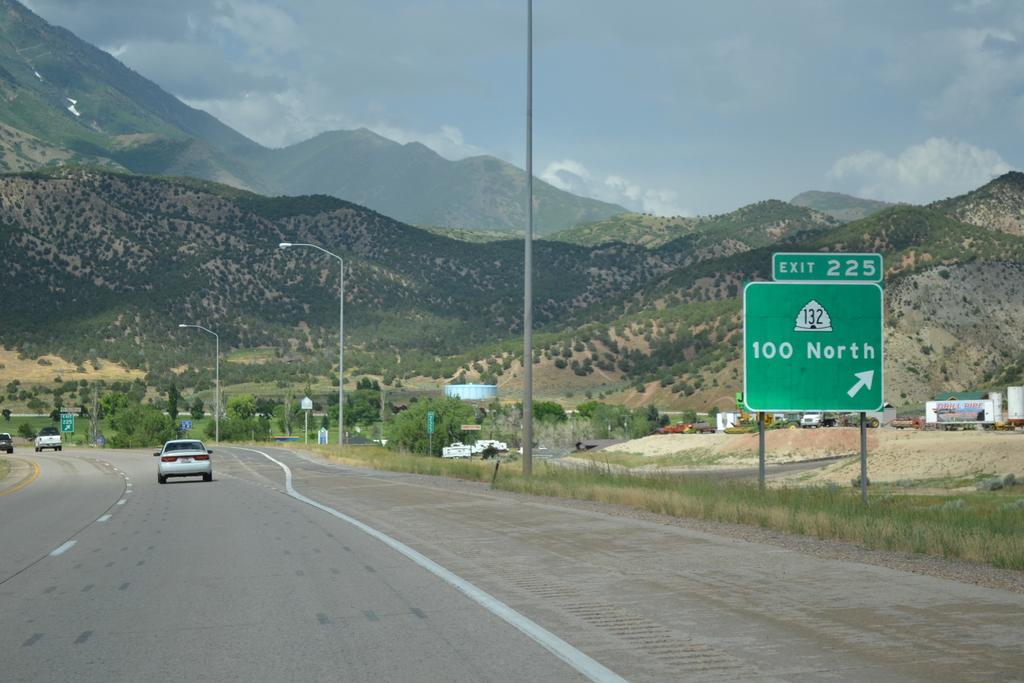Where is exit 225 heading?
Offer a terse response. 100 north. 